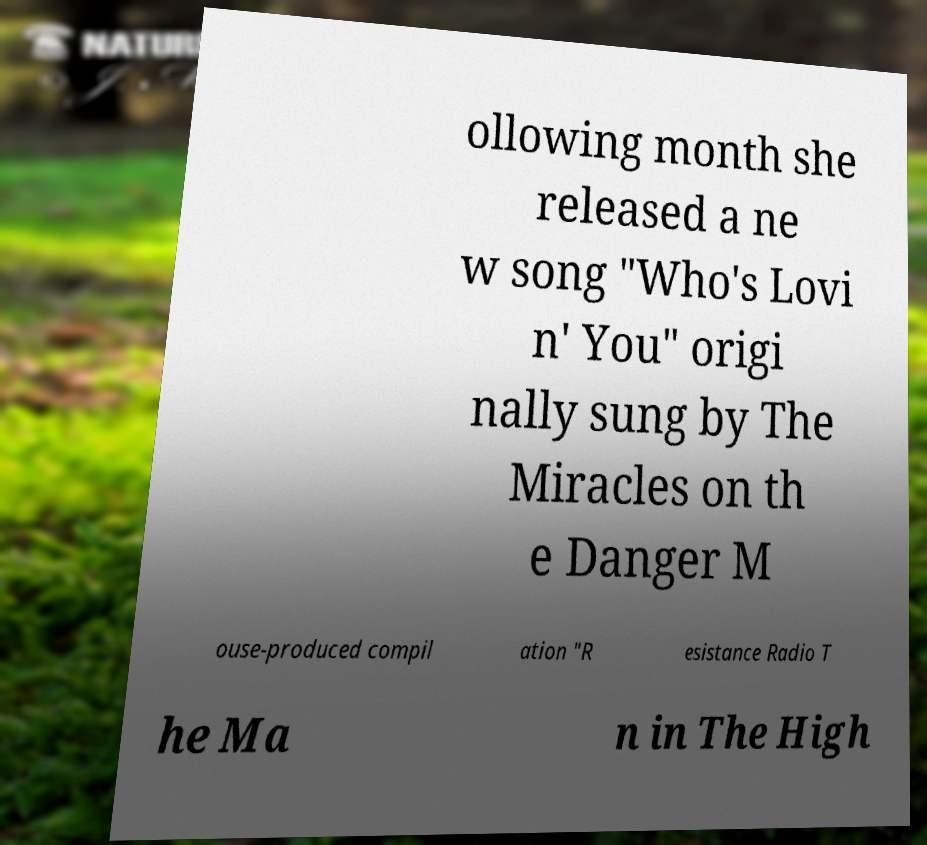Could you assist in decoding the text presented in this image and type it out clearly? ollowing month she released a ne w song "Who's Lovi n' You" origi nally sung by The Miracles on th e Danger M ouse-produced compil ation "R esistance Radio T he Ma n in The High 